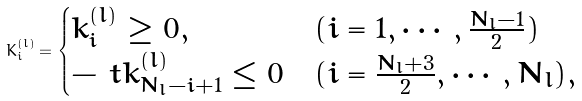Convert formula to latex. <formula><loc_0><loc_0><loc_500><loc_500>K _ { i } ^ { ( l ) } = \begin{cases} k _ { i } ^ { ( l ) } \geq 0 , & ( i = 1 , \cdots , \frac { N _ { l } - 1 } { 2 } ) \\ - \ t k _ { N _ { l } - i + 1 } ^ { ( l ) } \leq 0 & ( i = \frac { N _ { l } + 3 } { 2 } , \cdots , N _ { l } ) , \end{cases}</formula> 